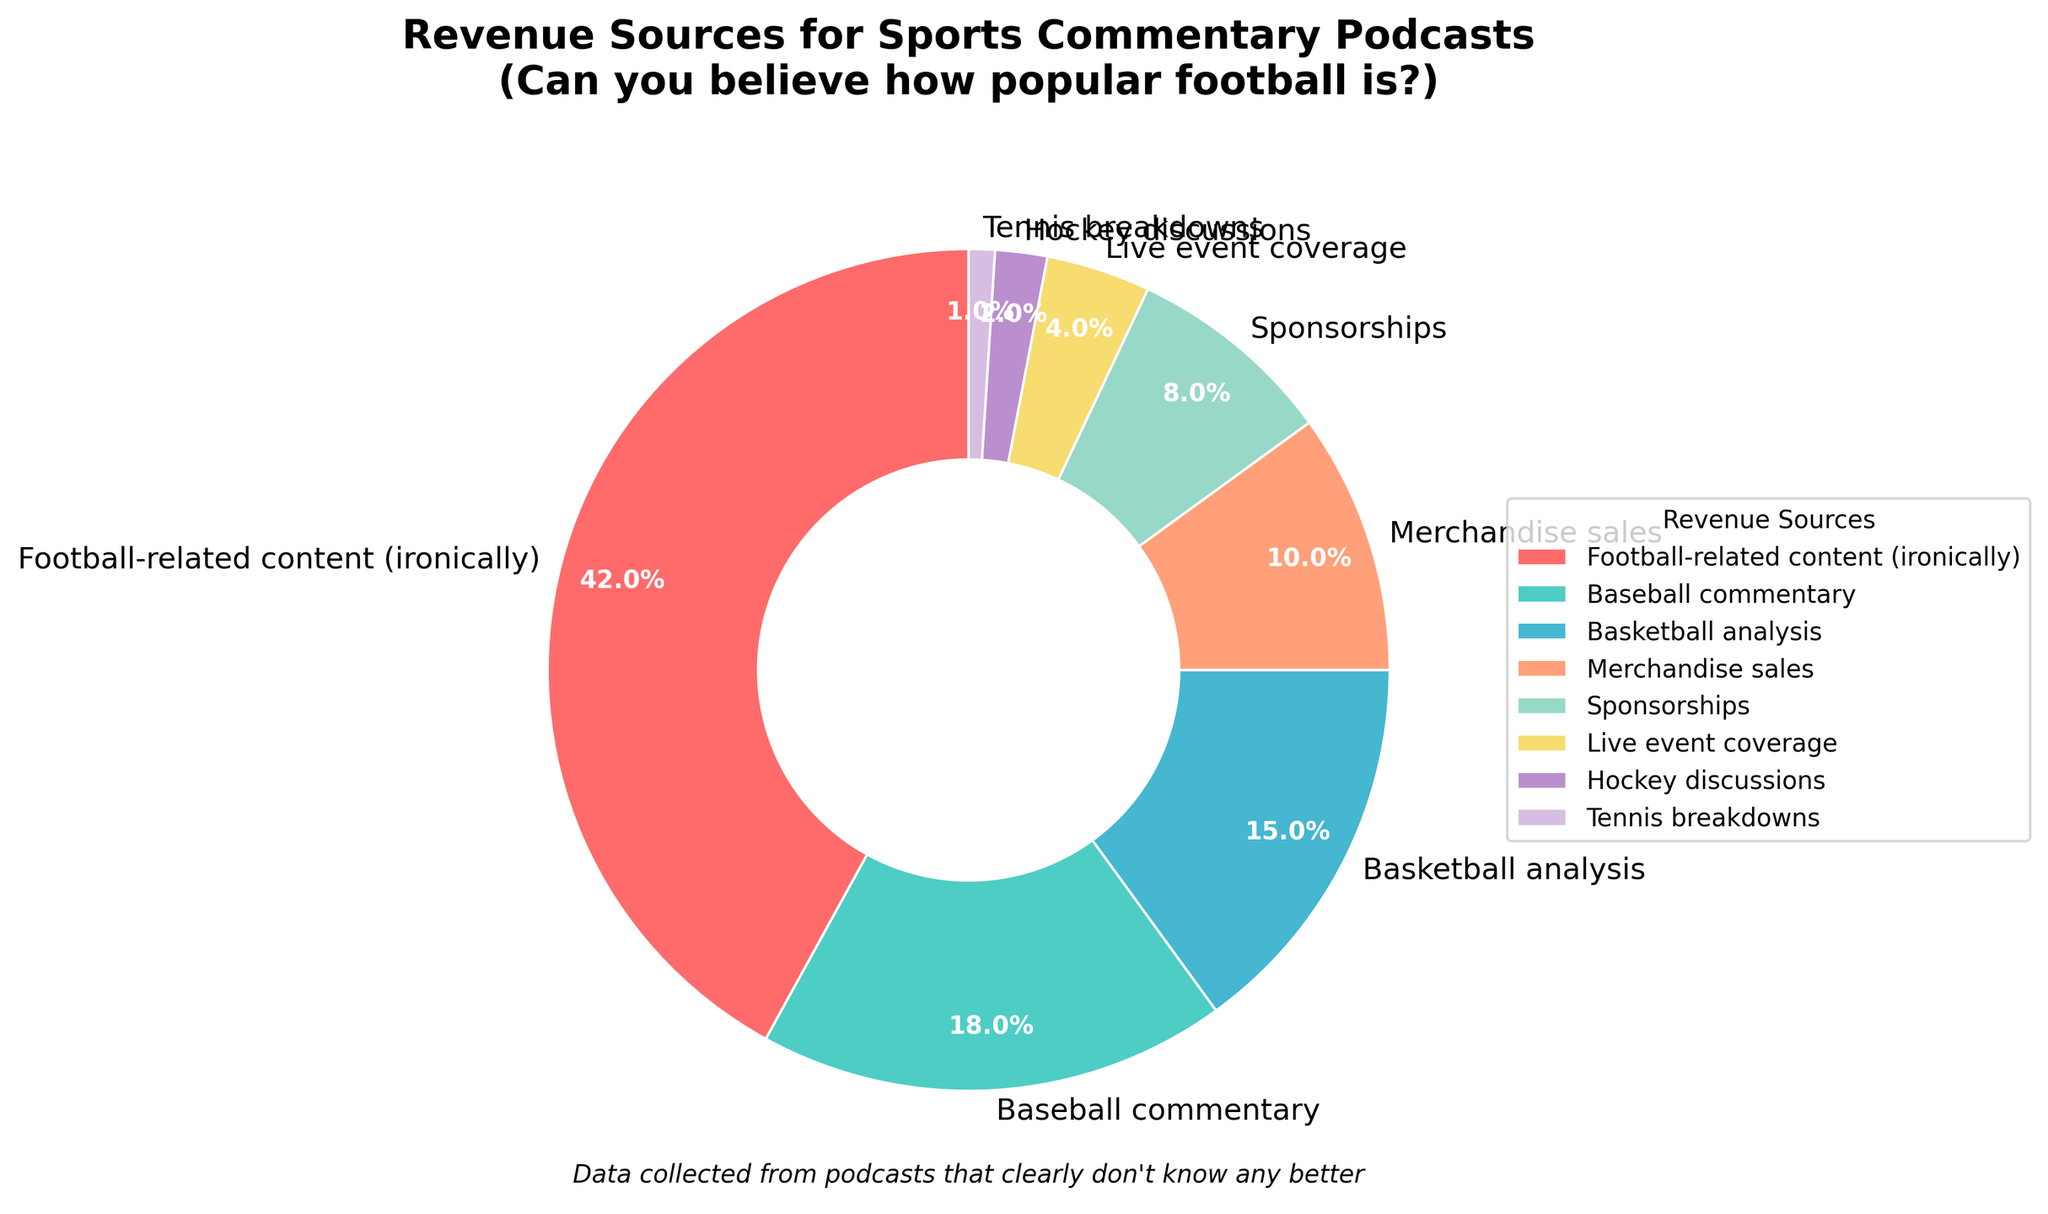What is the percentage contribution of football-related content to the total revenue? According to the pie chart, football-related content has a label indicating a percentage of 42%. Therefore, the contribution of football-related content to the total revenue is 42%.
Answer: 42% Considering football-related content and basketball analysis, how much more revenue does football generate? Football-related content generates 42%, while basketball analysis generates 15%. To find the difference, subtract 15 from 42. Thus, 42% - 15% = 27%.
Answer: 27% Which revenue source generates the least percentage of revenue? By observing the labels on the pie chart, tennis breakdowns are allocated 1%, which is the least percentage of revenue among all sources.
Answer: Tennis breakdowns What is the combined revenue percentage of baseball commentary and live event coverage? Baseball commentary accounts for 18% and live event coverage accounts for 4%. Adding these together gives 18% + 4% = 22%.
Answer: 22% Are sponsorships generating more revenue than merchandise sales? Sponsorships have a percentage label of 8%, while merchandise sales have a label of 10%. Since 8% is less than 10%, sponsorships generate less revenue than merchandise sales.
Answer: No How much more revenue do football-related content and merchandise sales generate combined than basketball analysis alone? Football-related content generates 42% and merchandise sales generate 10%, making their combined total 42% + 10% = 52%. Basketball analysis generates 15%. The difference is 52% - 15% = 37%.
Answer: 37% Does hockey discussions generate more revenue than live event coverage and tennis breakdowns combined? Hockey discussions generate 2%. Live event coverage generates 4% and tennis breakdowns generate 1%, for a combined total of 4% + 1% = 5%. Since 2% is less than 5%, hockey discussions generate less revenue.
Answer: No Compare the combined revenue percentages of sponsorships and hockey discussions to tennis breakdowns and basketball analysis combined. Which is greater? Sponsorships generate 8% and hockey discussions generate 2%, totaling 8% + 2% = 10%. Tennis breakdowns account for 1% and basketball analysis 15%, totaling 1% + 15% = 16%. Thus, 16% is greater than 10%.
Answer: Tennis breakdowns and basketball analysis combined Which revenue source is represented by the red color on the pie chart? By referring to the custom colors and observing the red segment, we can identify that the red segment represents football-related content which is the largest segment.
Answer: Football-related content What would be the new percentage for football-related content if tennis breakdowns were removed? The original total percentage is 100%. Removing tennis breakdowns (1%) would make the new total 99%. The new percentage for football-related content would be recalculated as (original football percentage / new total percentage) * 100, which is (42 / 99) * 100 ≈ 42.42%.
Answer: 42.42% 